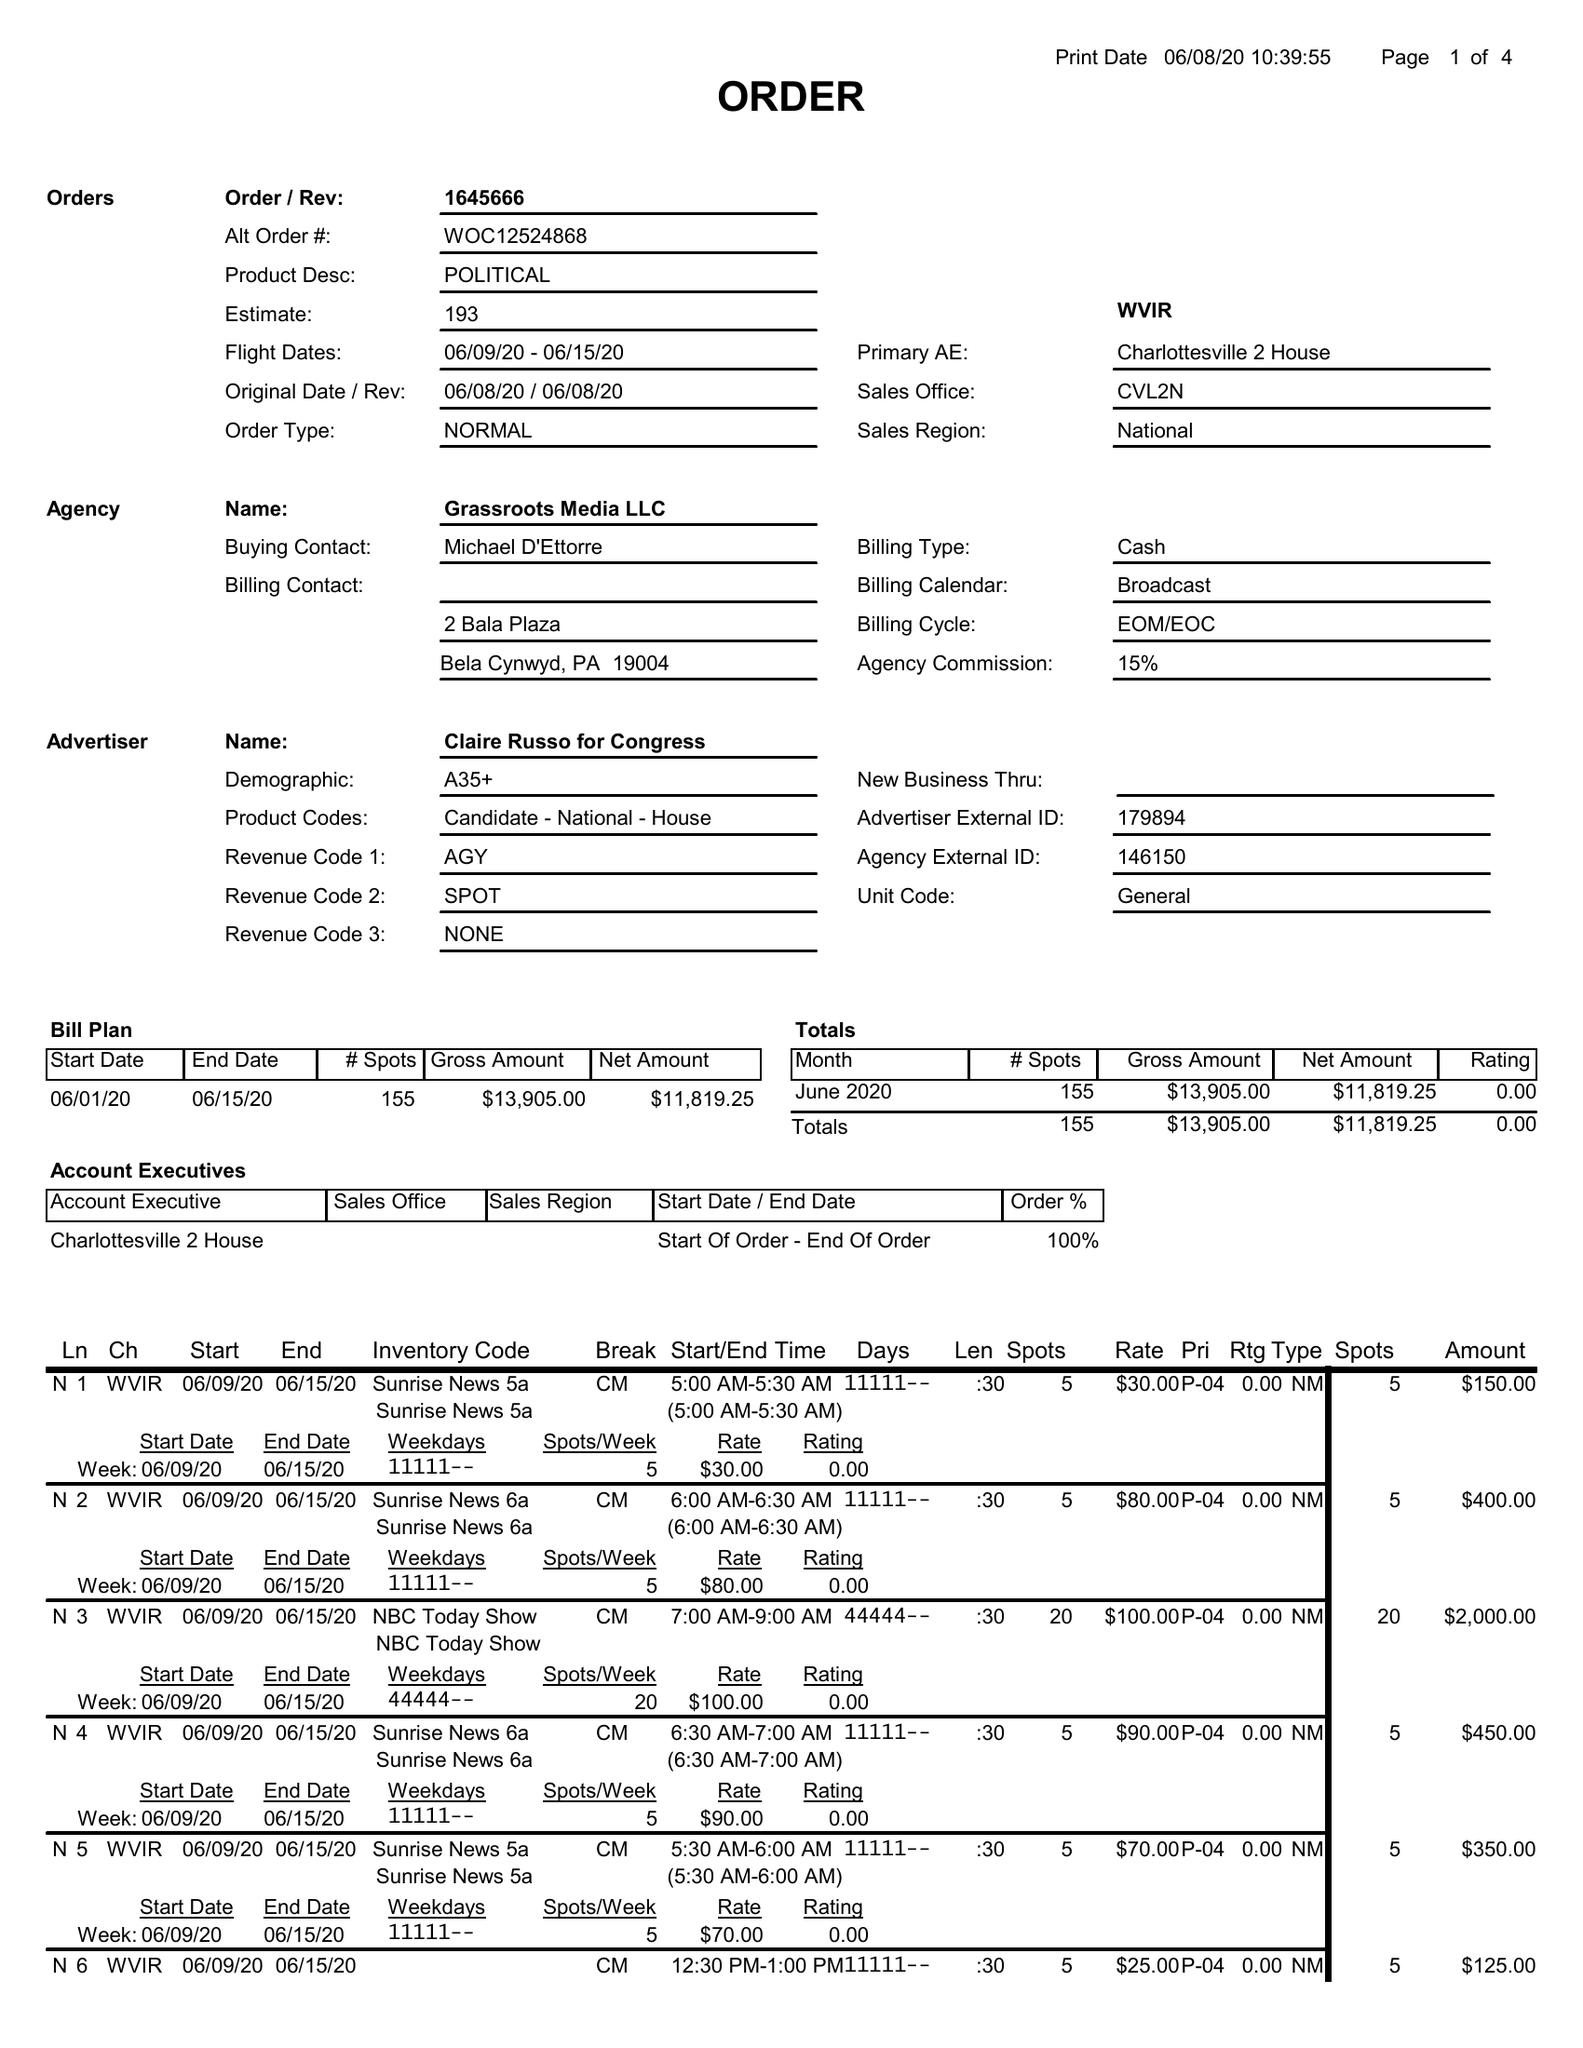What is the value for the flight_to?
Answer the question using a single word or phrase. 06/15/20 